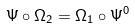<formula> <loc_0><loc_0><loc_500><loc_500>\Psi \circ \Omega _ { 2 } = \Omega _ { 1 } \circ \Psi ^ { 0 }</formula> 